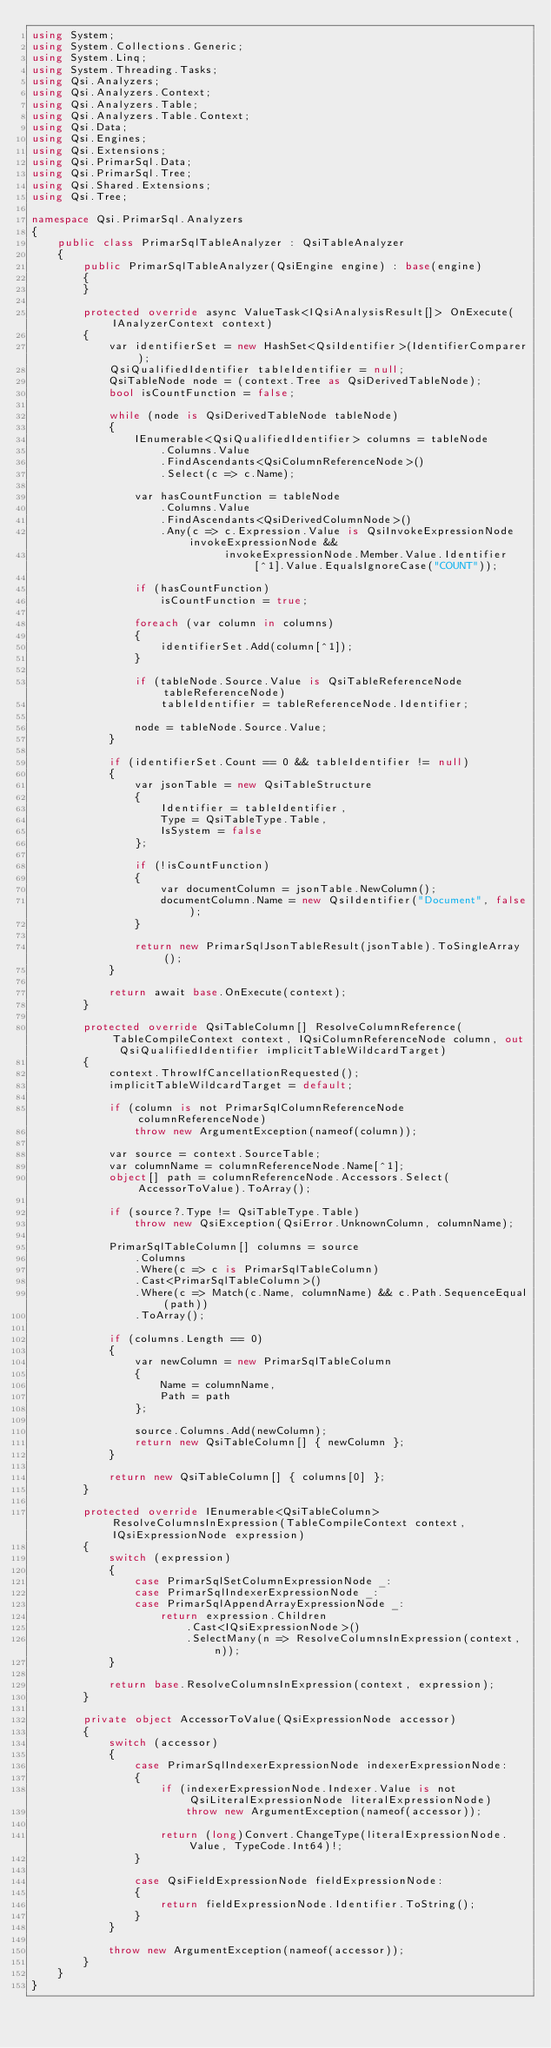Convert code to text. <code><loc_0><loc_0><loc_500><loc_500><_C#_>using System;
using System.Collections.Generic;
using System.Linq;
using System.Threading.Tasks;
using Qsi.Analyzers;
using Qsi.Analyzers.Context;
using Qsi.Analyzers.Table;
using Qsi.Analyzers.Table.Context;
using Qsi.Data;
using Qsi.Engines;
using Qsi.Extensions;
using Qsi.PrimarSql.Data;
using Qsi.PrimarSql.Tree;
using Qsi.Shared.Extensions;
using Qsi.Tree;

namespace Qsi.PrimarSql.Analyzers
{
    public class PrimarSqlTableAnalyzer : QsiTableAnalyzer
    {
        public PrimarSqlTableAnalyzer(QsiEngine engine) : base(engine)
        {
        }

        protected override async ValueTask<IQsiAnalysisResult[]> OnExecute(IAnalyzerContext context)
        {
            var identifierSet = new HashSet<QsiIdentifier>(IdentifierComparer);
            QsiQualifiedIdentifier tableIdentifier = null;
            QsiTableNode node = (context.Tree as QsiDerivedTableNode);
            bool isCountFunction = false;

            while (node is QsiDerivedTableNode tableNode)
            {
                IEnumerable<QsiQualifiedIdentifier> columns = tableNode
                    .Columns.Value
                    .FindAscendants<QsiColumnReferenceNode>()
                    .Select(c => c.Name);

                var hasCountFunction = tableNode
                    .Columns.Value
                    .FindAscendants<QsiDerivedColumnNode>()
                    .Any(c => c.Expression.Value is QsiInvokeExpressionNode invokeExpressionNode &&
                              invokeExpressionNode.Member.Value.Identifier[^1].Value.EqualsIgnoreCase("COUNT"));

                if (hasCountFunction)
                    isCountFunction = true;

                foreach (var column in columns)
                {
                    identifierSet.Add(column[^1]);
                }

                if (tableNode.Source.Value is QsiTableReferenceNode tableReferenceNode)
                    tableIdentifier = tableReferenceNode.Identifier;

                node = tableNode.Source.Value;
            }

            if (identifierSet.Count == 0 && tableIdentifier != null)
            {
                var jsonTable = new QsiTableStructure
                {
                    Identifier = tableIdentifier,
                    Type = QsiTableType.Table,
                    IsSystem = false
                };

                if (!isCountFunction)
                {
                    var documentColumn = jsonTable.NewColumn();
                    documentColumn.Name = new QsiIdentifier("Document", false);
                }

                return new PrimarSqlJsonTableResult(jsonTable).ToSingleArray();
            }

            return await base.OnExecute(context);
        }

        protected override QsiTableColumn[] ResolveColumnReference(TableCompileContext context, IQsiColumnReferenceNode column, out QsiQualifiedIdentifier implicitTableWildcardTarget)
        {
            context.ThrowIfCancellationRequested();
            implicitTableWildcardTarget = default;

            if (column is not PrimarSqlColumnReferenceNode columnReferenceNode)
                throw new ArgumentException(nameof(column));

            var source = context.SourceTable;
            var columnName = columnReferenceNode.Name[^1];
            object[] path = columnReferenceNode.Accessors.Select(AccessorToValue).ToArray();

            if (source?.Type != QsiTableType.Table)
                throw new QsiException(QsiError.UnknownColumn, columnName);

            PrimarSqlTableColumn[] columns = source
                .Columns
                .Where(c => c is PrimarSqlTableColumn)
                .Cast<PrimarSqlTableColumn>()
                .Where(c => Match(c.Name, columnName) && c.Path.SequenceEqual(path))
                .ToArray();

            if (columns.Length == 0)
            {
                var newColumn = new PrimarSqlTableColumn
                {
                    Name = columnName,
                    Path = path
                };

                source.Columns.Add(newColumn);
                return new QsiTableColumn[] { newColumn };
            }

            return new QsiTableColumn[] { columns[0] };
        }

        protected override IEnumerable<QsiTableColumn> ResolveColumnsInExpression(TableCompileContext context, IQsiExpressionNode expression)
        {
            switch (expression)
            {
                case PrimarSqlSetColumnExpressionNode _:
                case PrimarSqlIndexerExpressionNode _:
                case PrimarSqlAppendArrayExpressionNode _:
                    return expression.Children
                        .Cast<IQsiExpressionNode>()
                        .SelectMany(n => ResolveColumnsInExpression(context, n));
            }

            return base.ResolveColumnsInExpression(context, expression);
        }

        private object AccessorToValue(QsiExpressionNode accessor)
        {
            switch (accessor)
            {
                case PrimarSqlIndexerExpressionNode indexerExpressionNode:
                {
                    if (indexerExpressionNode.Indexer.Value is not QsiLiteralExpressionNode literalExpressionNode)
                        throw new ArgumentException(nameof(accessor));

                    return (long)Convert.ChangeType(literalExpressionNode.Value, TypeCode.Int64)!;
                }

                case QsiFieldExpressionNode fieldExpressionNode:
                {
                    return fieldExpressionNode.Identifier.ToString();
                }
            }

            throw new ArgumentException(nameof(accessor));
        }
    }
}
</code> 